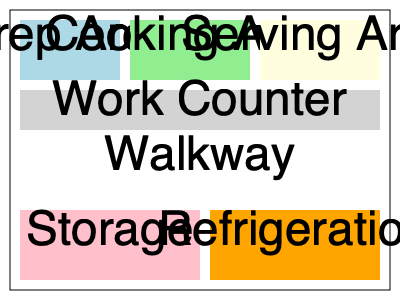In the given food truck floor plan, which area is strategically placed between the prep area and the serving area to optimize workflow? To answer this question, let's analyze the floor plan of the food truck:

1. The floor plan is divided into several distinct areas.
2. On the left side, we can see the prep area, which is where ingredients are prepared.
3. On the right side, we find the serving area, where food is handed to customers.
4. Between these two areas, we can clearly see the cooking area.
5. The placement of the cooking area between prep and serving is strategic because:
   a) It allows for a smooth workflow from preparation to cooking to serving.
   b) It minimizes movement within the confined space of the food truck.
   c) It creates an efficient "assembly line" style of food production.
6. This arrangement optimizes the workspace by reducing unnecessary back-and-forth movement and keeping the food preparation process linear and organized.

Therefore, the cooking area is strategically placed between the prep area and the serving area to optimize workflow in the food truck.
Answer: Cooking Area 